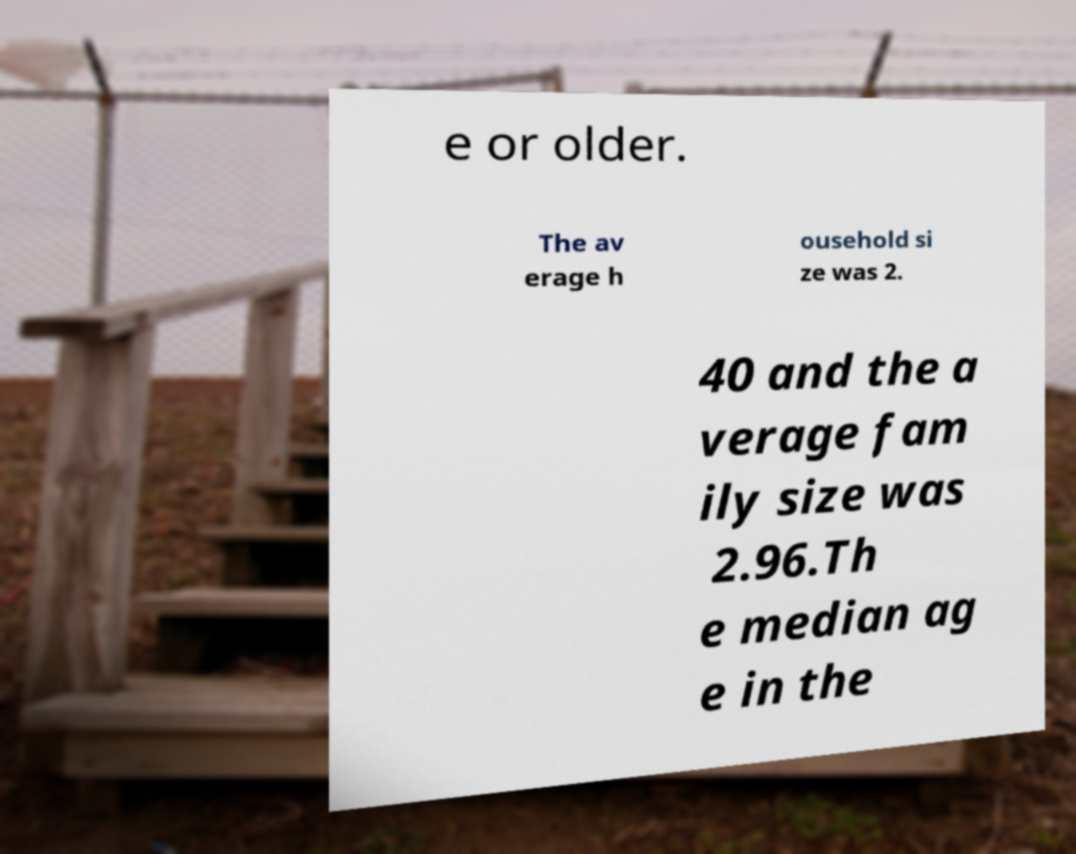For documentation purposes, I need the text within this image transcribed. Could you provide that? e or older. The av erage h ousehold si ze was 2. 40 and the a verage fam ily size was 2.96.Th e median ag e in the 